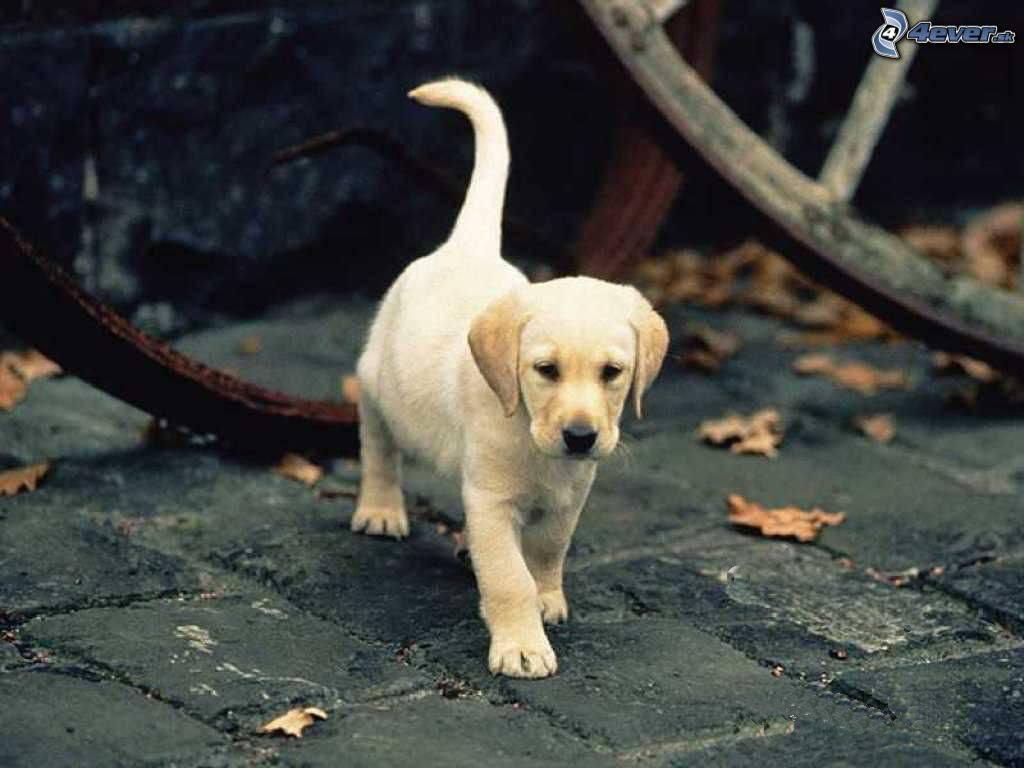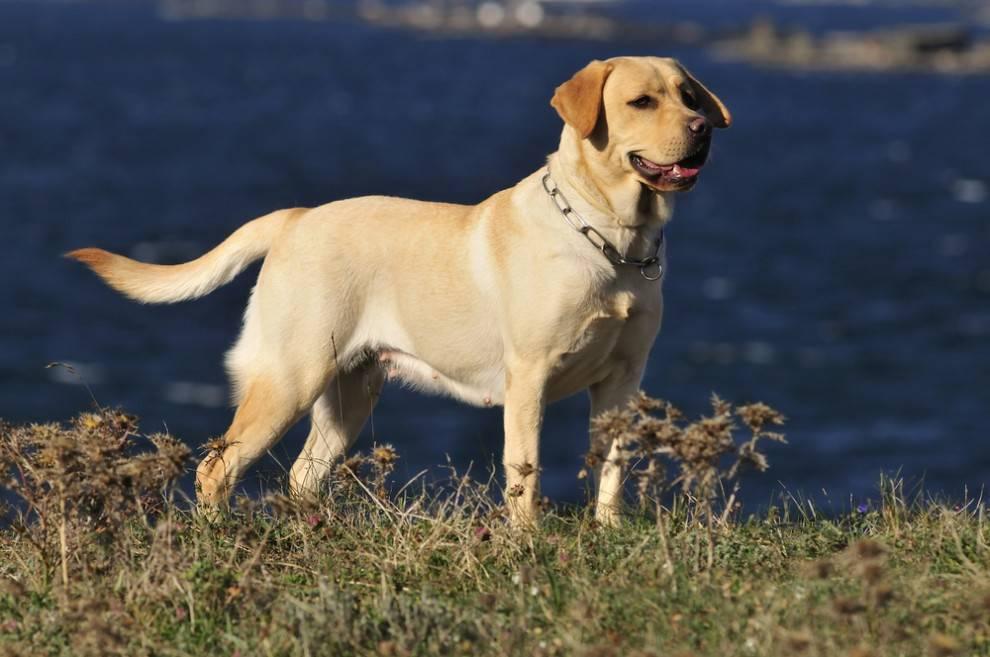The first image is the image on the left, the second image is the image on the right. Examine the images to the left and right. Is the description "One dog has at least two paws on cement." accurate? Answer yes or no. Yes. 